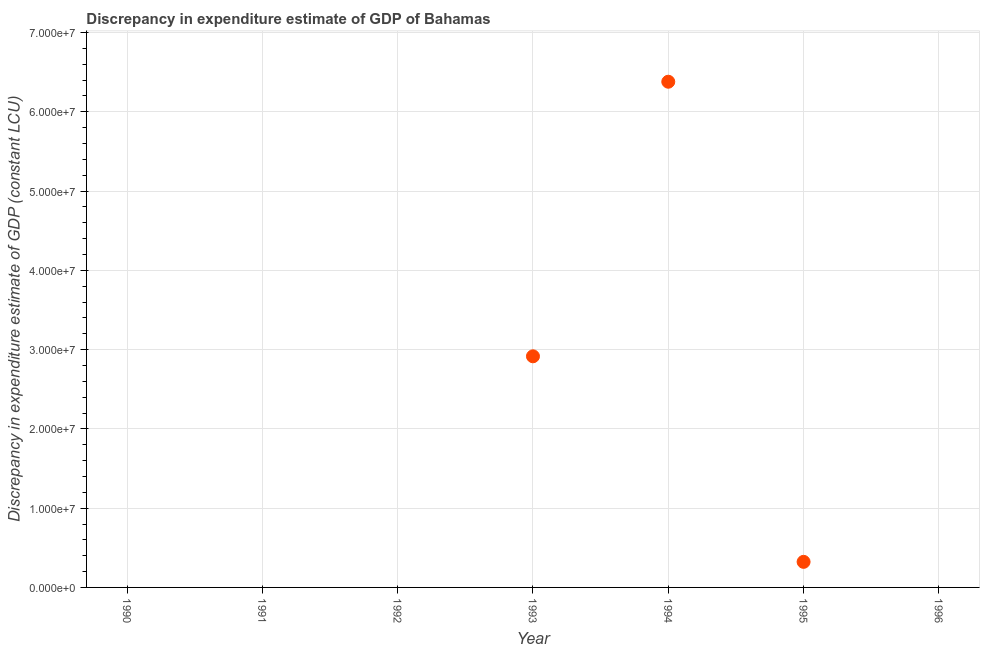Across all years, what is the maximum discrepancy in expenditure estimate of gdp?
Make the answer very short. 6.38e+07. Across all years, what is the minimum discrepancy in expenditure estimate of gdp?
Your answer should be very brief. 0. In which year was the discrepancy in expenditure estimate of gdp maximum?
Give a very brief answer. 1994. What is the sum of the discrepancy in expenditure estimate of gdp?
Provide a short and direct response. 9.62e+07. What is the difference between the discrepancy in expenditure estimate of gdp in 1993 and 1995?
Make the answer very short. 2.59e+07. What is the average discrepancy in expenditure estimate of gdp per year?
Your answer should be compact. 1.37e+07. In how many years, is the discrepancy in expenditure estimate of gdp greater than 8000000 LCU?
Ensure brevity in your answer.  2. Is the difference between the discrepancy in expenditure estimate of gdp in 1993 and 1994 greater than the difference between any two years?
Make the answer very short. No. What is the difference between the highest and the second highest discrepancy in expenditure estimate of gdp?
Ensure brevity in your answer.  3.46e+07. What is the difference between the highest and the lowest discrepancy in expenditure estimate of gdp?
Offer a terse response. 6.38e+07. Does the discrepancy in expenditure estimate of gdp monotonically increase over the years?
Your answer should be compact. No. How many years are there in the graph?
Your answer should be compact. 7. What is the difference between two consecutive major ticks on the Y-axis?
Your answer should be very brief. 1.00e+07. Does the graph contain grids?
Make the answer very short. Yes. What is the title of the graph?
Your answer should be very brief. Discrepancy in expenditure estimate of GDP of Bahamas. What is the label or title of the Y-axis?
Your response must be concise. Discrepancy in expenditure estimate of GDP (constant LCU). What is the Discrepancy in expenditure estimate of GDP (constant LCU) in 1990?
Offer a terse response. 0. What is the Discrepancy in expenditure estimate of GDP (constant LCU) in 1993?
Ensure brevity in your answer.  2.92e+07. What is the Discrepancy in expenditure estimate of GDP (constant LCU) in 1994?
Make the answer very short. 6.38e+07. What is the Discrepancy in expenditure estimate of GDP (constant LCU) in 1995?
Keep it short and to the point. 3.23e+06. What is the Discrepancy in expenditure estimate of GDP (constant LCU) in 1996?
Your response must be concise. 0. What is the difference between the Discrepancy in expenditure estimate of GDP (constant LCU) in 1993 and 1994?
Offer a very short reply. -3.46e+07. What is the difference between the Discrepancy in expenditure estimate of GDP (constant LCU) in 1993 and 1995?
Your answer should be very brief. 2.59e+07. What is the difference between the Discrepancy in expenditure estimate of GDP (constant LCU) in 1994 and 1995?
Ensure brevity in your answer.  6.06e+07. What is the ratio of the Discrepancy in expenditure estimate of GDP (constant LCU) in 1993 to that in 1994?
Your response must be concise. 0.46. What is the ratio of the Discrepancy in expenditure estimate of GDP (constant LCU) in 1993 to that in 1995?
Offer a very short reply. 9.04. What is the ratio of the Discrepancy in expenditure estimate of GDP (constant LCU) in 1994 to that in 1995?
Keep it short and to the point. 19.78. 